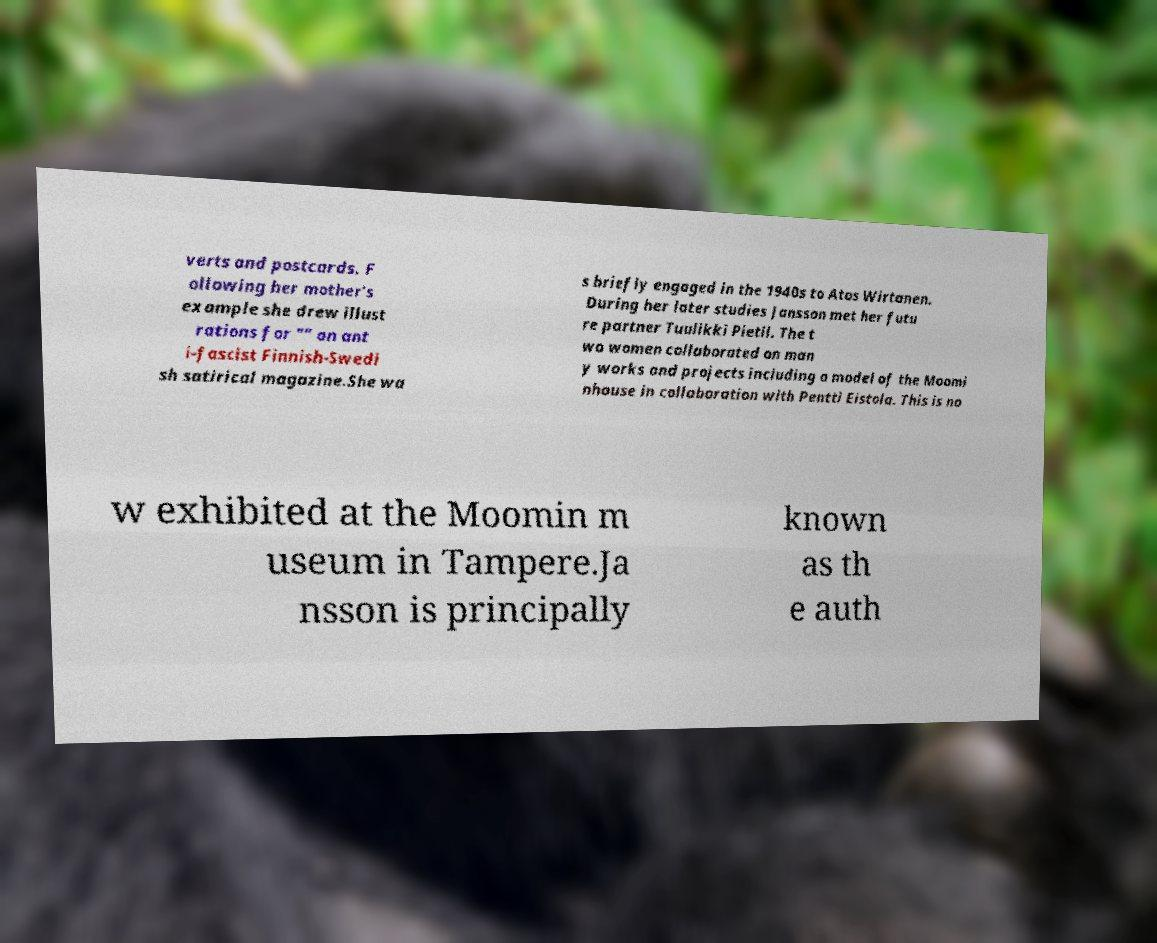There's text embedded in this image that I need extracted. Can you transcribe it verbatim? verts and postcards. F ollowing her mother's example she drew illust rations for "" an ant i-fascist Finnish-Swedi sh satirical magazine.She wa s briefly engaged in the 1940s to Atos Wirtanen. During her later studies Jansson met her futu re partner Tuulikki Pietil. The t wo women collaborated on man y works and projects including a model of the Moomi nhouse in collaboration with Pentti Eistola. This is no w exhibited at the Moomin m useum in Tampere.Ja nsson is principally known as th e auth 